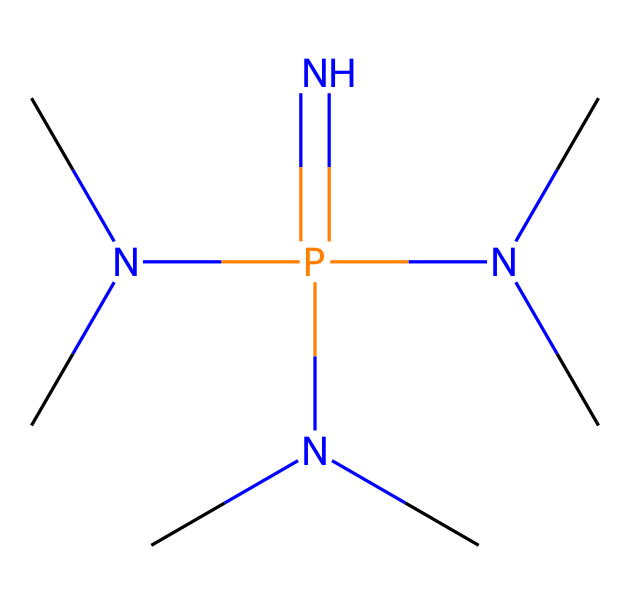What is the central atom in this chemical structure? The central atom is phosphorus, indicated by the P in the SMILES notation and its position in the molecular structure at the center of the phosphazene base.
Answer: phosphorus How many nitrogen atoms are present in the structure? By analyzing the SMILES representation, we can count the occurrences of nitrogen, represented by N. There are four nitrogen atoms surrounding the phosphorus central atom.
Answer: four What type of functional groups are present in this chemical? The functional groups are amine groups, as indicated by the multiple nitrogen atoms bonded to carbon and their structure that confirms the presence of -N(C)2 groups, where C represents alkyl groups.
Answer: amine Is this compound a superbase? Yes, phosphazene bases are known to be superbases due to the high basicity of the nitrogen atoms and their ability to accept protons efficiently.
Answer: yes What is the basic structure formed by this chemical? The basic structure involves a phosphorus atom bonded to four nitrogen atoms, three of which are substituted with alkyl groups, typically forming a cyclic or branched structure around the phosphorus atom.
Answer: phosphazene Which atoms are surrounding the phosphorus atom? The phosphorus atom is surrounded by four nitrogen atoms in its coordination sphere, with each nitrogen further bonded to carbon atoms.
Answer: nitrogen atoms 